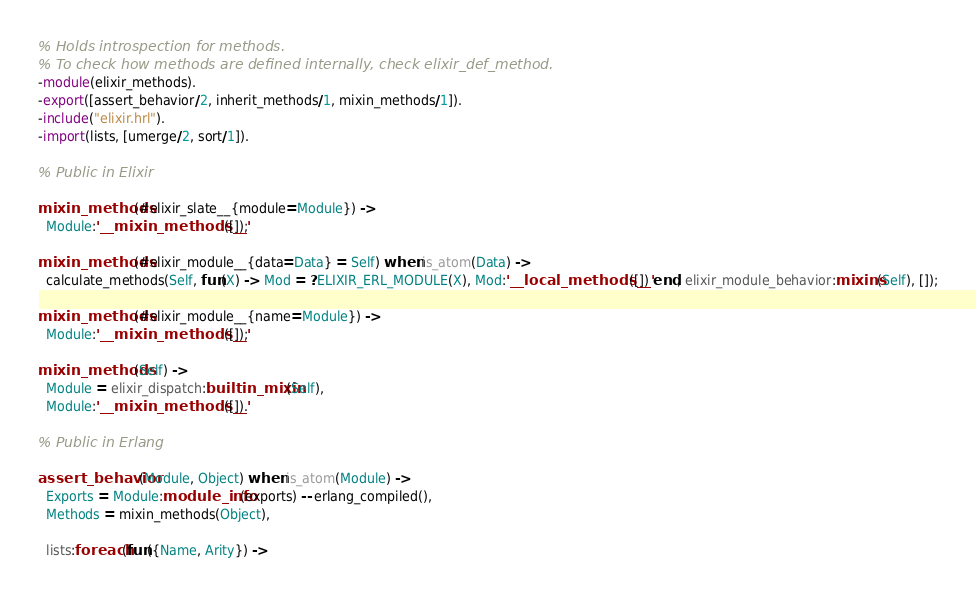Convert code to text. <code><loc_0><loc_0><loc_500><loc_500><_Erlang_>% Holds introspection for methods.
% To check how methods are defined internally, check elixir_def_method.
-module(elixir_methods).
-export([assert_behavior/2, inherit_methods/1, mixin_methods/1]).
-include("elixir.hrl").
-import(lists, [umerge/2, sort/1]).

% Public in Elixir

mixin_methods(#elixir_slate__{module=Module}) ->
  Module:'__mixin_methods__'([]);

mixin_methods(#elixir_module__{data=Data} = Self) when is_atom(Data) ->
  calculate_methods(Self, fun(X) -> Mod = ?ELIXIR_ERL_MODULE(X), Mod:'__local_methods__'([]) end, elixir_module_behavior:mixins(Self), []);

mixin_methods(#elixir_module__{name=Module}) ->
  Module:'__mixin_methods__'([]);

mixin_methods(Self) ->
  Module = elixir_dispatch:builtin_mixin(Self),
  Module:'__mixin_methods__'([]).

% Public in Erlang

assert_behavior(Module, Object) when is_atom(Module) -> 
  Exports = Module:module_info(exports) -- erlang_compiled(),
  Methods = mixin_methods(Object),

  lists:foreach(fun({Name, Arity}) -></code> 